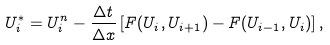<formula> <loc_0><loc_0><loc_500><loc_500>U _ { i } ^ { * } = U _ { i } ^ { n } - \frac { \Delta t } { \Delta x } \left [ { F } ( U _ { i } , U _ { i + 1 } ) - { F } ( U _ { i - 1 } , U _ { i } ) \right ] ,</formula> 